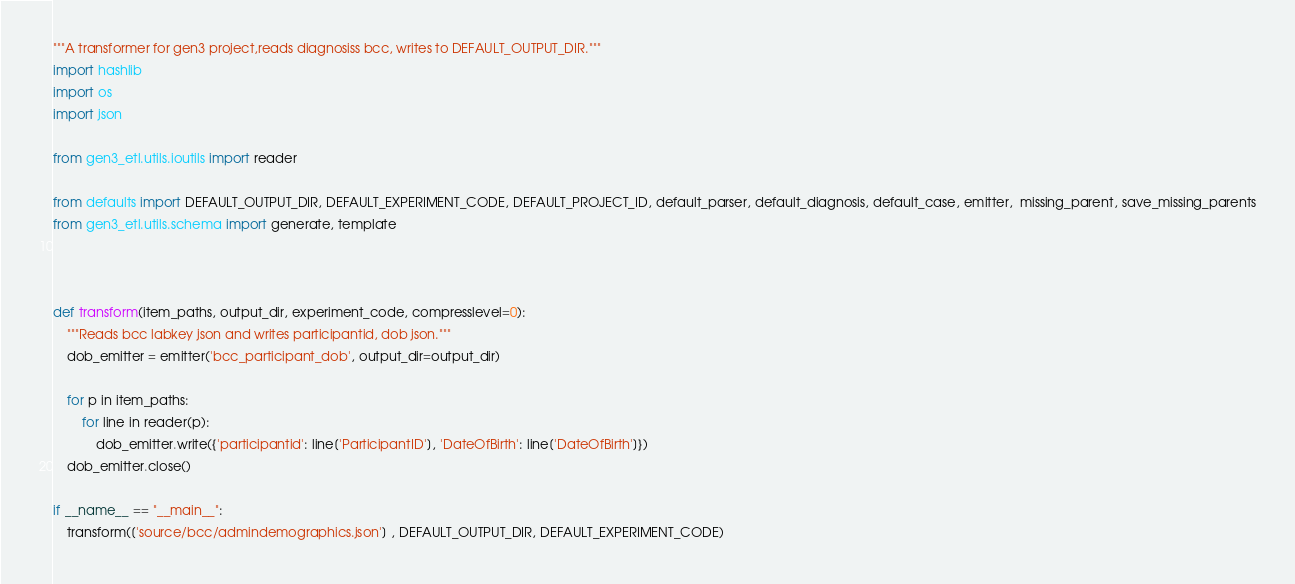Convert code to text. <code><loc_0><loc_0><loc_500><loc_500><_Python_>"""A transformer for gen3 project,reads diagnosiss bcc, writes to DEFAULT_OUTPUT_DIR."""
import hashlib
import os
import json

from gen3_etl.utils.ioutils import reader

from defaults import DEFAULT_OUTPUT_DIR, DEFAULT_EXPERIMENT_CODE, DEFAULT_PROJECT_ID, default_parser, default_diagnosis, default_case, emitter,  missing_parent, save_missing_parents
from gen3_etl.utils.schema import generate, template



def transform(item_paths, output_dir, experiment_code, compresslevel=0):
    """Reads bcc labkey json and writes participantid, dob json."""
    dob_emitter = emitter('bcc_participant_dob', output_dir=output_dir)

    for p in item_paths:
        for line in reader(p):
            dob_emitter.write({'participantid': line['ParticipantID'], 'DateOfBirth': line['DateOfBirth']})
    dob_emitter.close()

if __name__ == "__main__":
    transform(['source/bcc/admindemographics.json'] , DEFAULT_OUTPUT_DIR, DEFAULT_EXPERIMENT_CODE)
</code> 